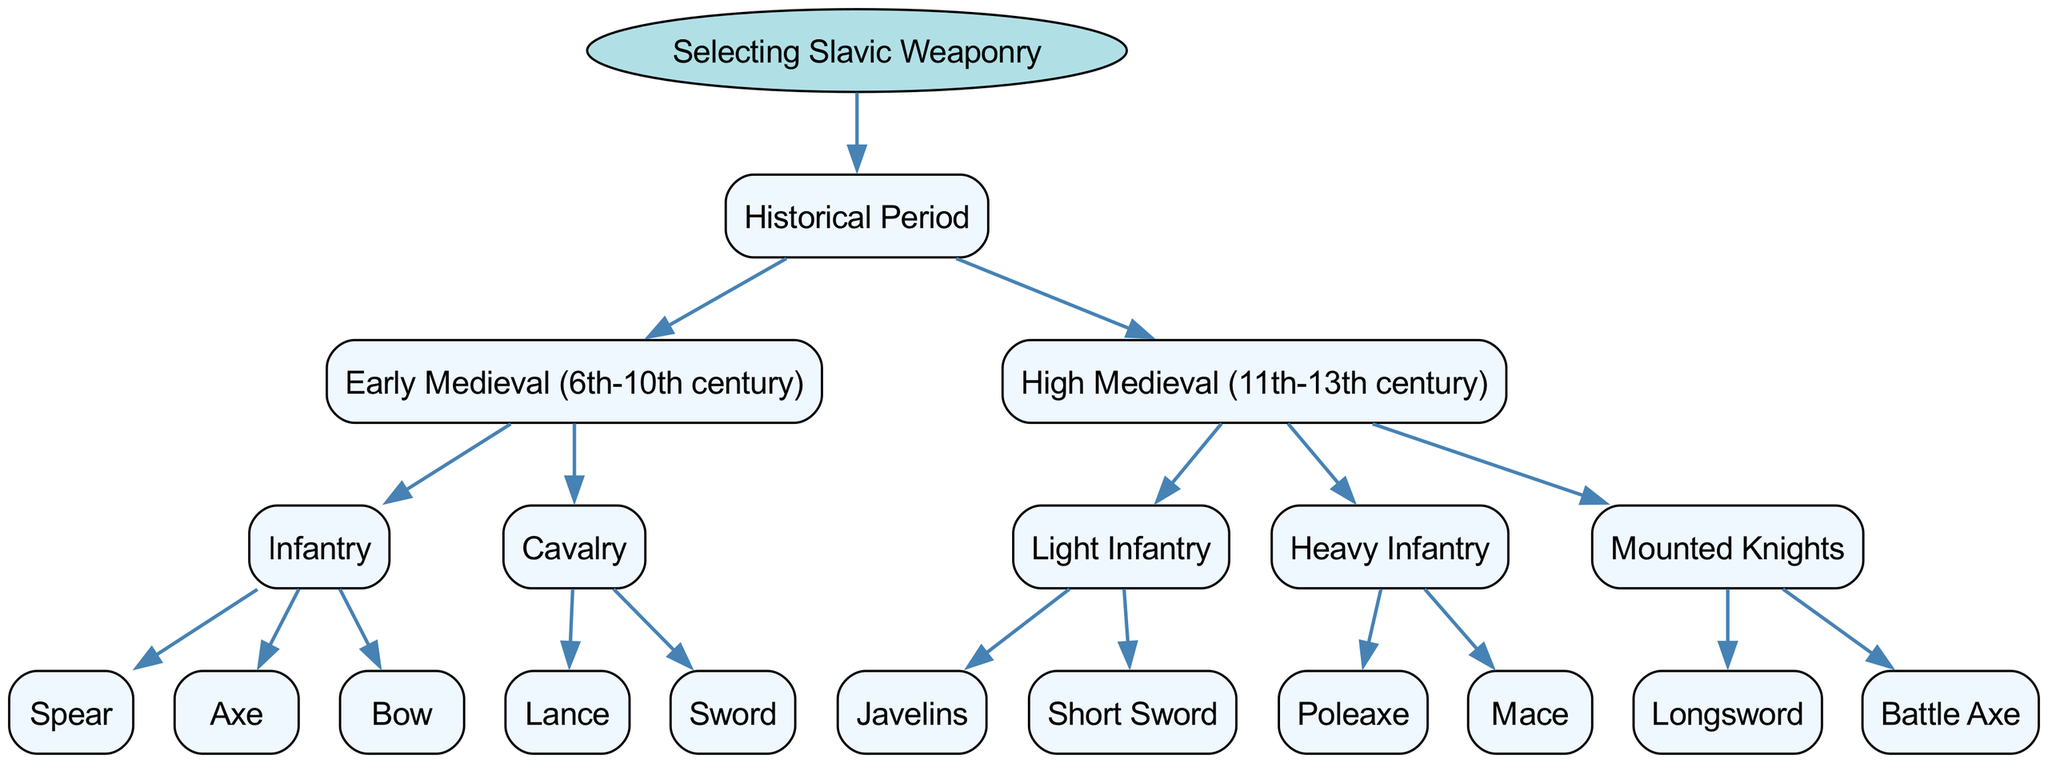What is the root of the decision tree? The root of the decision tree is the topmost node that represents the overall category, which in this case is "Selecting Slavic Weaponry".
Answer: Selecting Slavic Weaponry How many historical periods are represented in the diagram? By examining the child nodes under the root, we see there are two historical periods: "Early Medieval (6th-10th century)" and "High Medieval (11th-13th century)".
Answer: 2 What type of weapon is associated with Heavy Infantry in the High Medieval period? To find this, we look at the "Heavy Infantry" node under the "High Medieval" period, which lists "Poleaxe" and "Mace".
Answer: Poleaxe Which weapon is not included in the Early Medieval infantry? The weapons available for the Early Medieval infantry include "Spear", "Axe", and "Bow". The question asks for a weapon not in that list. The answer requires knowledge of common medieval weapons to infer an answer like the "Longsword".
Answer: Longsword What is the difference between Cavalry and Infantry in the Early Medieval period? To answer this, we look at the nodes under the "Early Medieval" period. "Infantry" includes weapons like "Spear", "Axe", and "Bow", whereas "Cavalry" includes "Lance" and "Sword". This establishes that Cavalry uses longer reach, mounted combat weapons whereas Infantry uses a variety of footsoldier weapons.
Answer: Cavalry uses mounted combat weapons, Infantry uses footsoldier weapons Which type of weapon is listed as a common choice for Mounted Knights? The "Mounted Knights" section of the "High Medieval" period shows choices of "Longsword" and "Battle Axe". Either could be correct, but since the question asks for a common type, "Longsword" is typically favored in chivalric contexts.
Answer: Longsword What type of weapon is primarily associated with Light Infantry? By evaluating the "Light Infantry" node under "High Medieval", it lists "Javelins" and "Short Sword". Either would suffice, however, "Javelins" are generally more associated with light infantry due to their throwing capability.
Answer: Javelins How many types of cavalry weapons are there in the Early Medieval period? The "Cavalry" node under "Early Medieval" lists "Lance" and "Sword". By counting these weapons, we find there are two types.
Answer: 2 